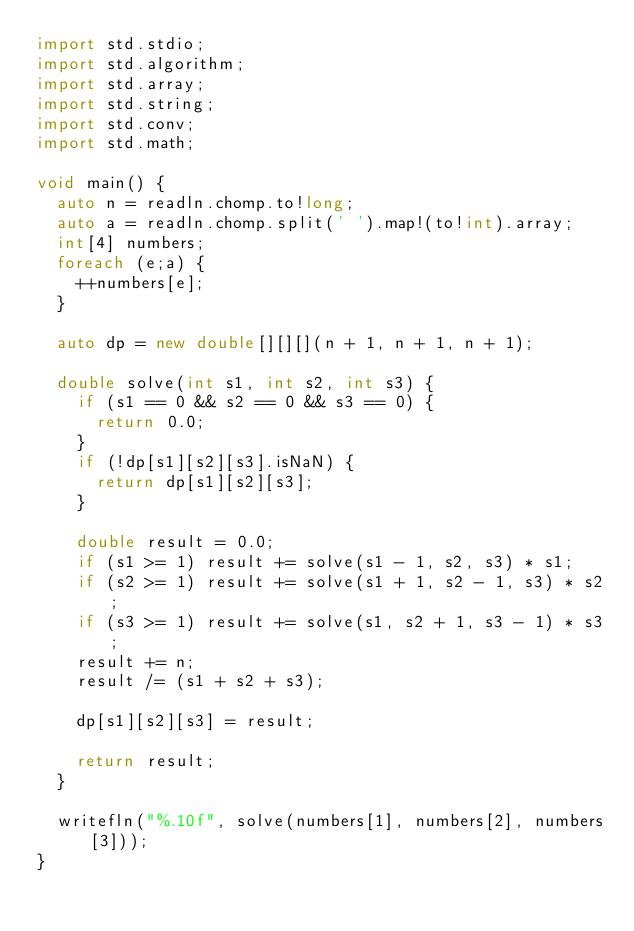Convert code to text. <code><loc_0><loc_0><loc_500><loc_500><_D_>import std.stdio;
import std.algorithm;
import std.array;
import std.string;
import std.conv;
import std.math;

void main() {
	auto n = readln.chomp.to!long;
	auto a = readln.chomp.split(' ').map!(to!int).array;
	int[4] numbers;
	foreach (e;a) {
		++numbers[e];
	}

	auto dp = new double[][][](n + 1, n + 1, n + 1);

	double solve(int s1, int s2, int s3) {
		if (s1 == 0 && s2 == 0 && s3 == 0) {
			return 0.0;
		}
		if (!dp[s1][s2][s3].isNaN) {
			return dp[s1][s2][s3];
		}

		double result = 0.0;
		if (s1 >= 1) result += solve(s1 - 1, s2, s3) * s1;
		if (s2 >= 1) result += solve(s1 + 1, s2 - 1, s3) * s2;
		if (s3 >= 1) result += solve(s1, s2 + 1, s3 - 1) * s3;
		result += n;
		result /= (s1 + s2 + s3);

		dp[s1][s2][s3] = result;

		return result;
	}

	writefln("%.10f", solve(numbers[1], numbers[2], numbers[3]));
}
</code> 